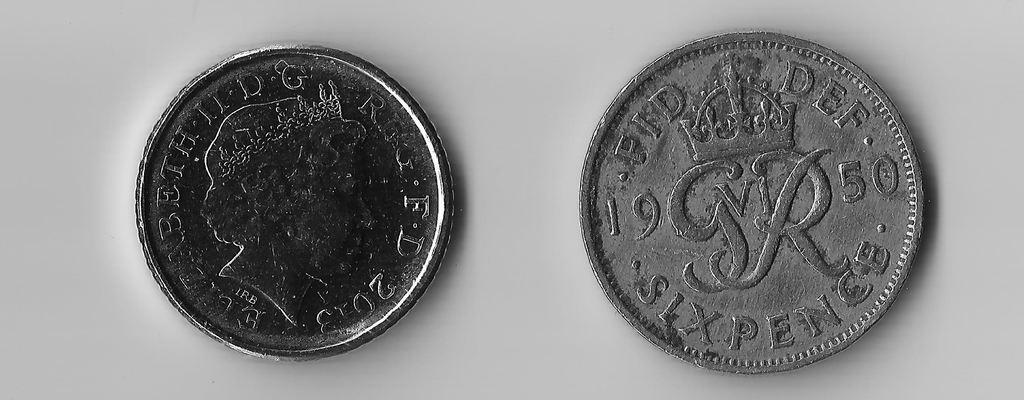<image>
Describe the image concisely. Two silver coins with sixpence and a crown on it. 